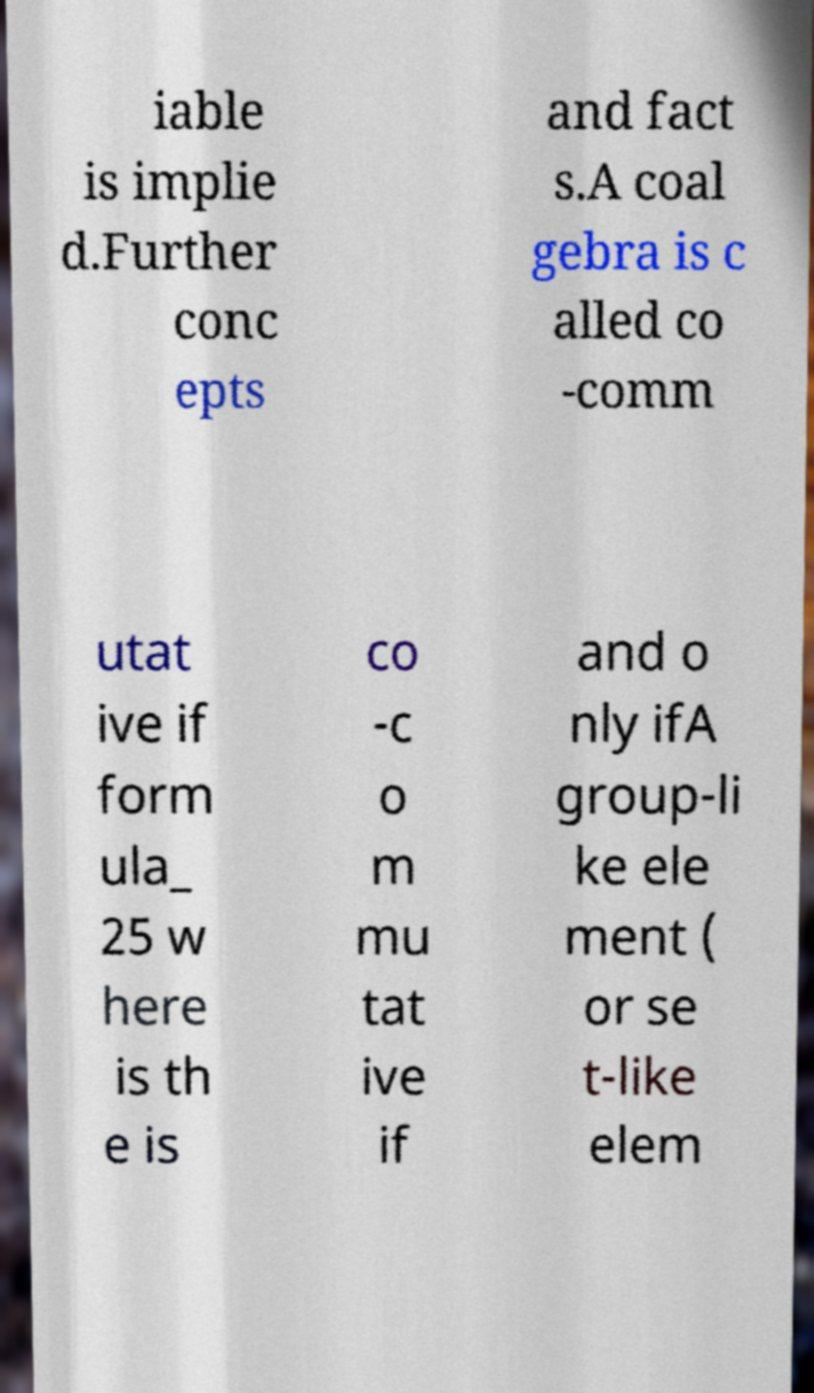Could you extract and type out the text from this image? iable is implie d.Further conc epts and fact s.A coal gebra is c alled co -comm utat ive if form ula_ 25 w here is th e is co -c o m mu tat ive if and o nly ifA group-li ke ele ment ( or se t-like elem 